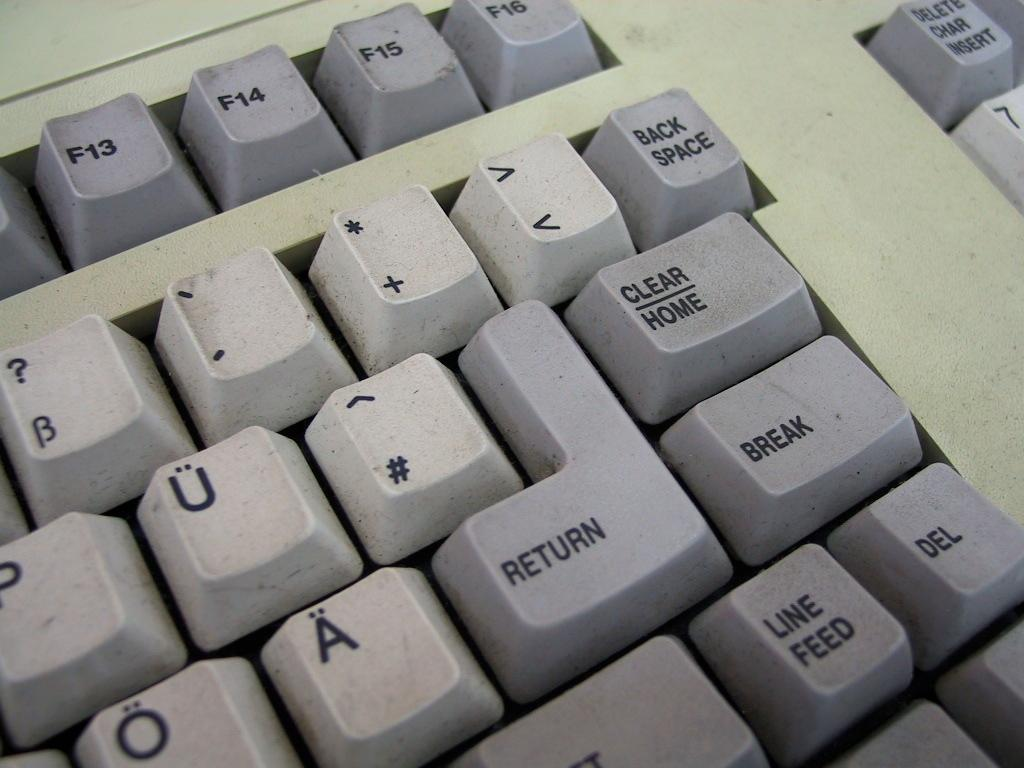<image>
Write a terse but informative summary of the picture. A closeup of a keyboard with a large RETURN key 